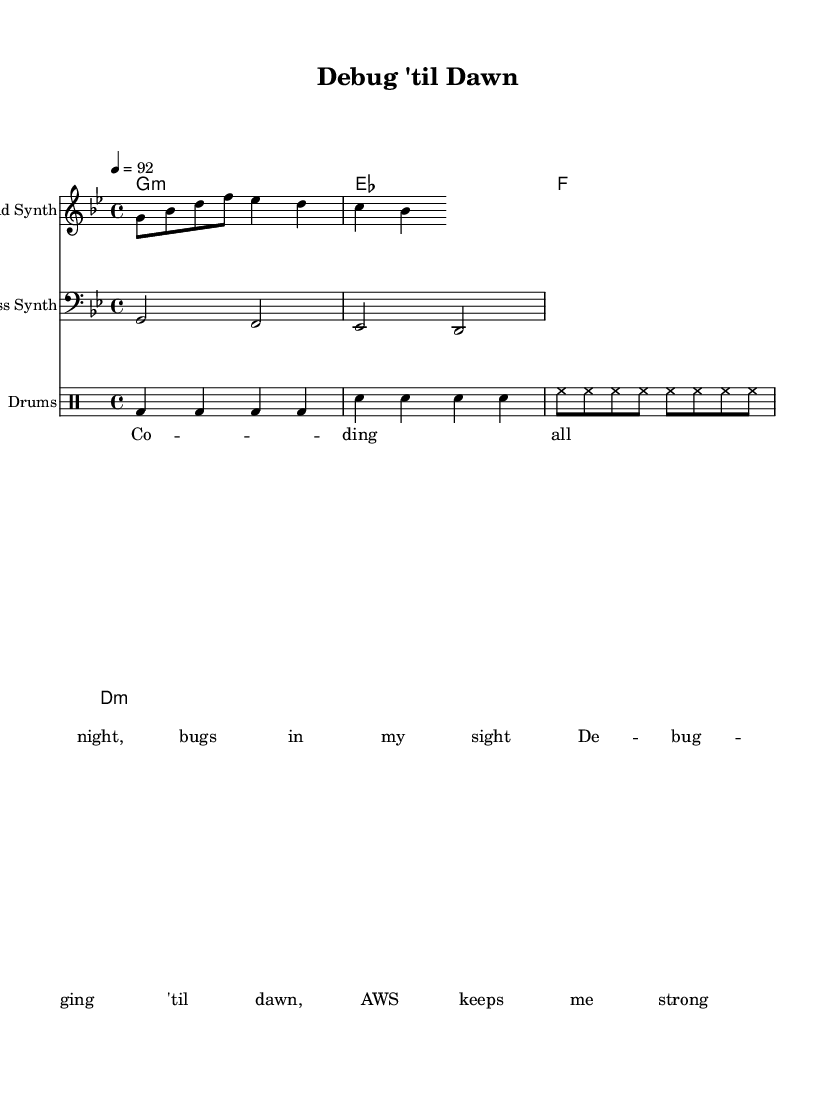What is the key signature of this music? The key signature is G minor, indicated by the presence of two flats (B♭ and E♭) in the key signature.
Answer: G minor What is the time signature of this music? The time signature is 4/4, which means there are four beats in each measure, and the quarter note gets one beat, as indicated at the beginning of the score.
Answer: 4/4 What tempo marking is used in this music? The tempo marking is indicated as 92 beats per minute, which specifies the speed at which the piece should be played.
Answer: 92 How many measures does the drum pattern consist of? The drum pattern consists of four measures, as the repeating symbols indicate four sets of beats organized within a standard structure for rhythm.
Answer: Four What instrument serves as the lead part in this piece? The lead part is played by the Lead Synth, as indicated in the score with the appropriate instrumentation listed at the beginning of the staff.
Answer: Lead Synth What is the main theme expressed in the lyrics? The lyrics express a theme of late-night coding and debugging challenges, highlighting the perseverance required to overcome technical issues.
Answer: Coding all night Why is the choice of "AWS" significant in this piece? The mention of "AWS" relates to technology and programming, representing the use of modern cloud services that support development processes, which is central to the hip-hop theme of coding and tech-savviness.
Answer: Represents cloud services 